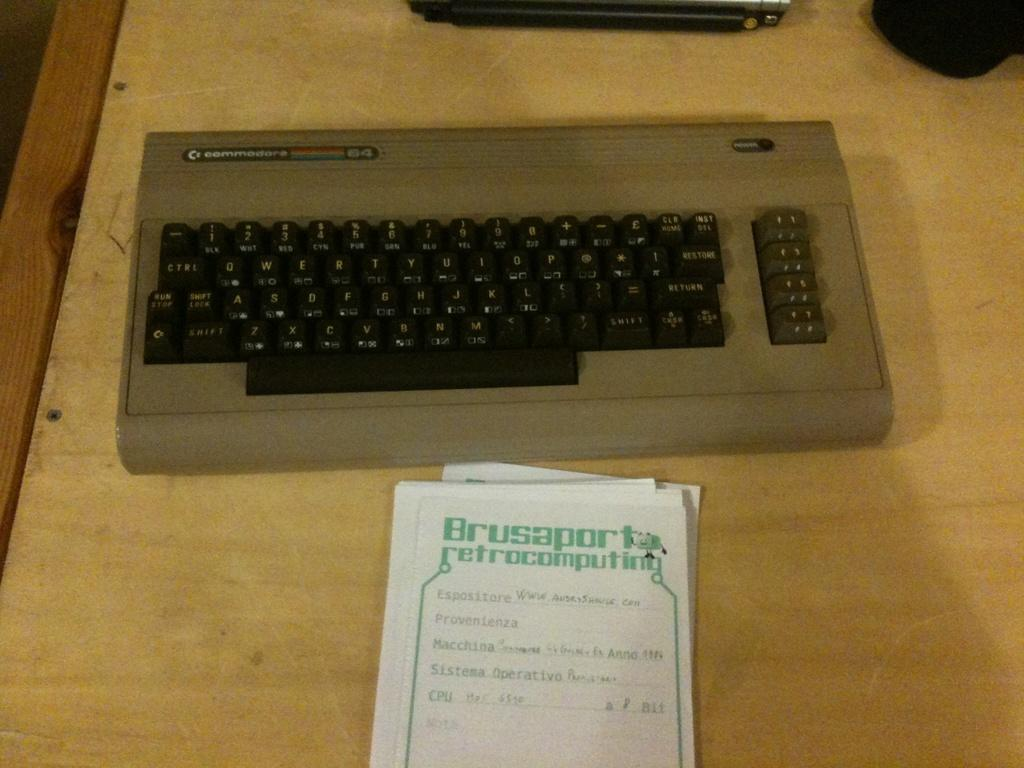<image>
Write a terse but informative summary of the picture. A small mechanical keyboard witha a leaflet for brusaport retrocomputing. 